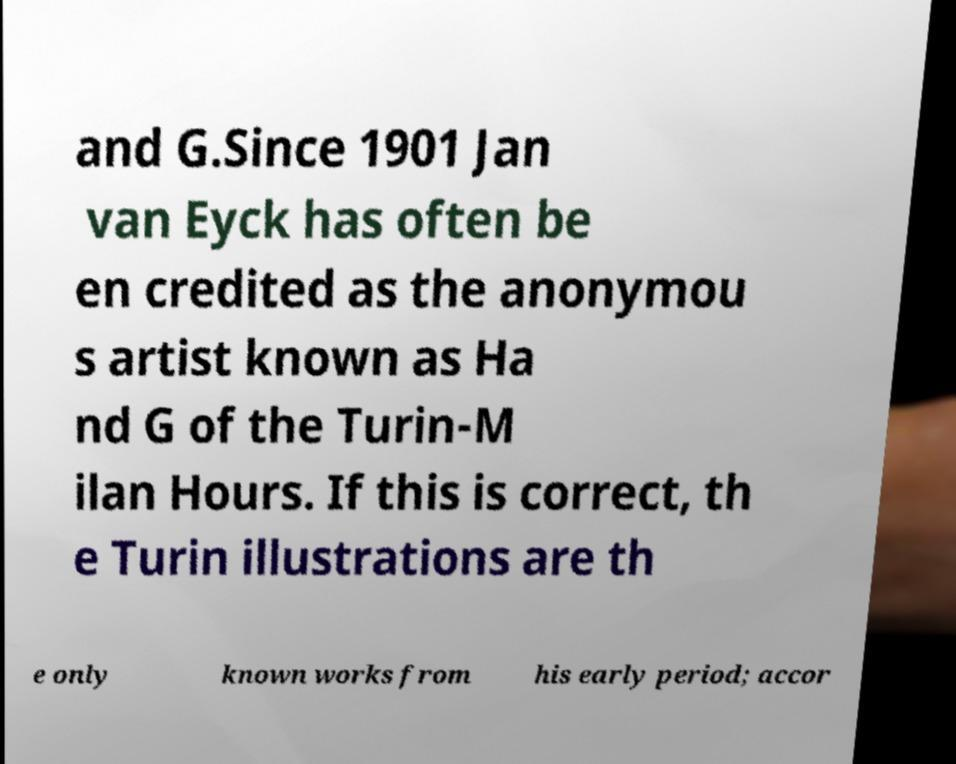Could you assist in decoding the text presented in this image and type it out clearly? and G.Since 1901 Jan van Eyck has often be en credited as the anonymou s artist known as Ha nd G of the Turin-M ilan Hours. If this is correct, th e Turin illustrations are th e only known works from his early period; accor 